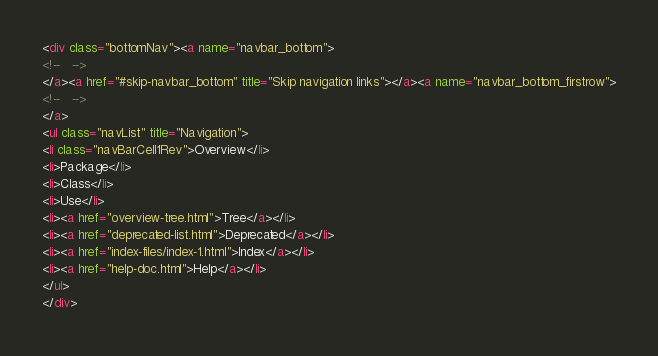<code> <loc_0><loc_0><loc_500><loc_500><_HTML_><div class="bottomNav"><a name="navbar_bottom">
<!--   -->
</a><a href="#skip-navbar_bottom" title="Skip navigation links"></a><a name="navbar_bottom_firstrow">
<!--   -->
</a>
<ul class="navList" title="Navigation">
<li class="navBarCell1Rev">Overview</li>
<li>Package</li>
<li>Class</li>
<li>Use</li>
<li><a href="overview-tree.html">Tree</a></li>
<li><a href="deprecated-list.html">Deprecated</a></li>
<li><a href="index-files/index-1.html">Index</a></li>
<li><a href="help-doc.html">Help</a></li>
</ul>
</div></code> 